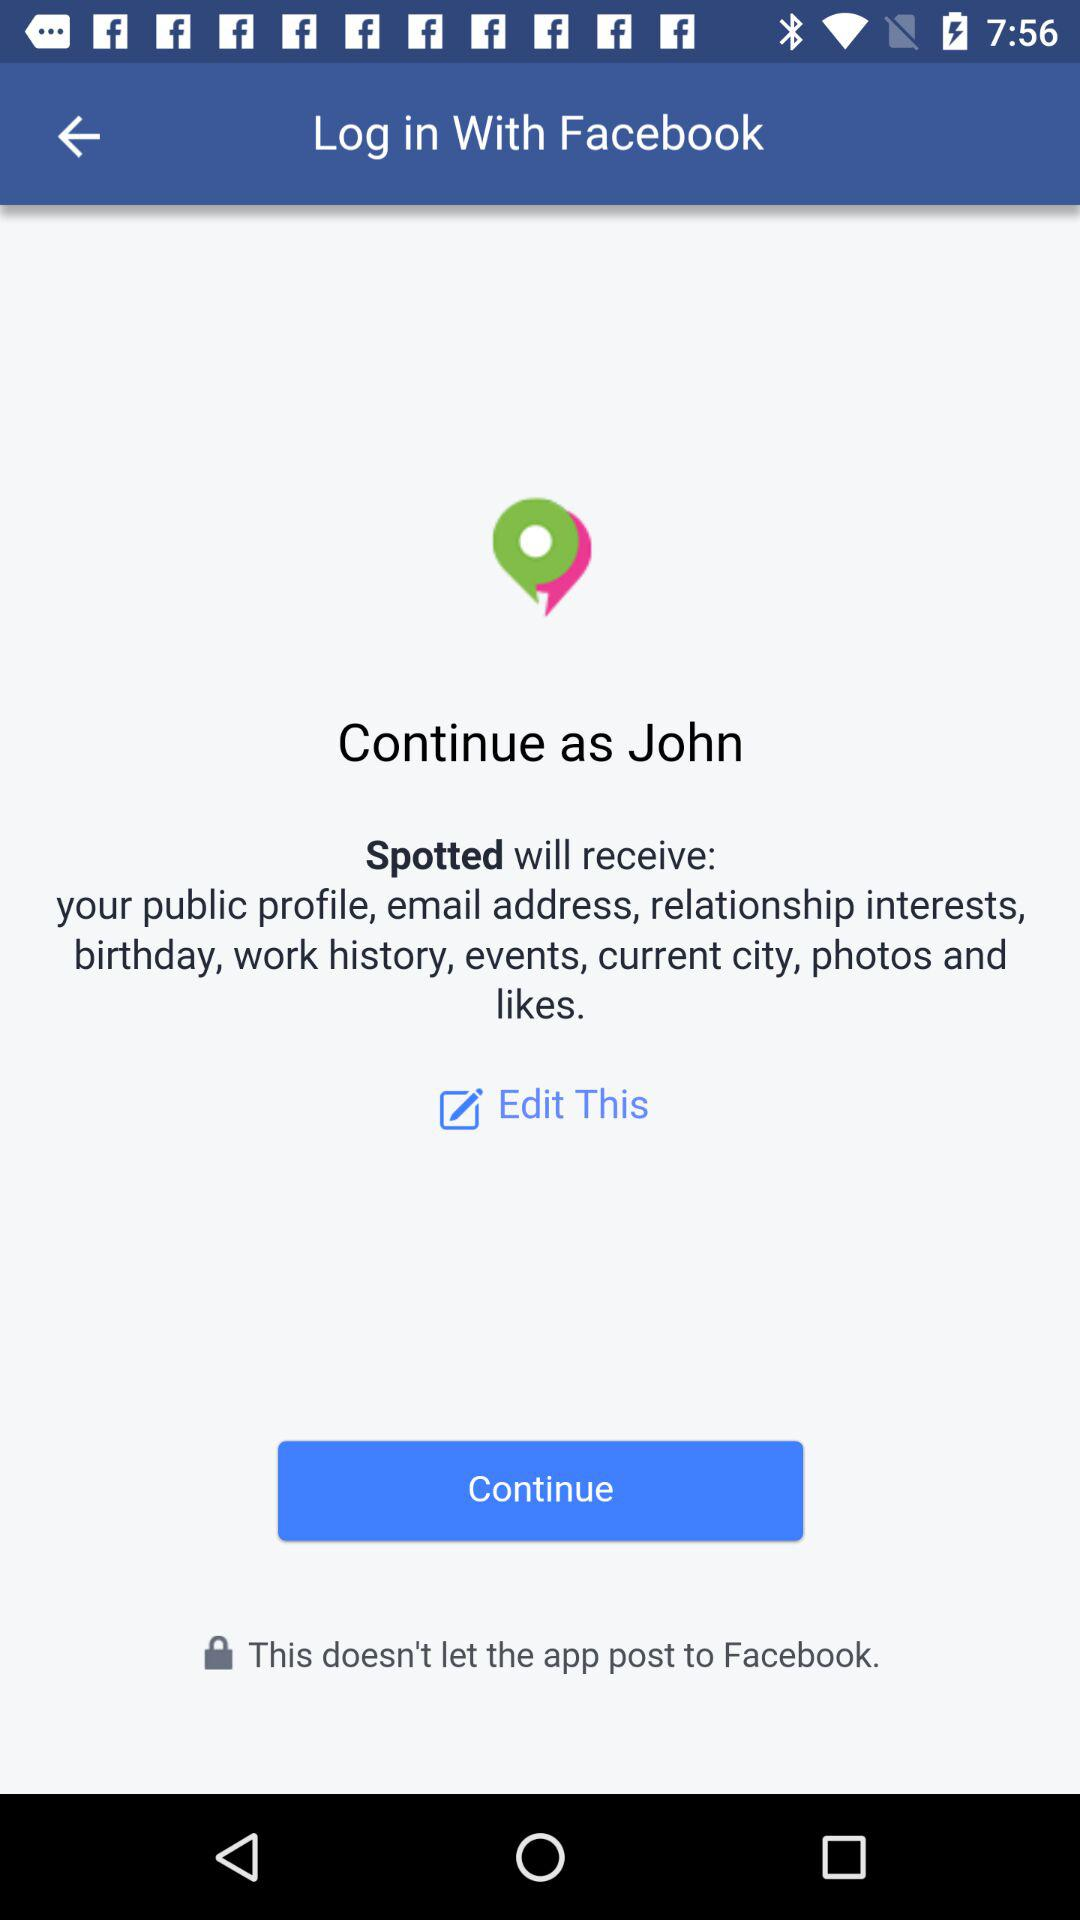What application will receive your public profile, email address, relationship interests, birthday, work history, events, current city, photos and likes? The application is "Spotted". 